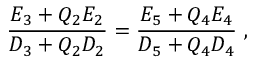<formula> <loc_0><loc_0><loc_500><loc_500>\frac { E _ { 3 } + Q _ { 2 } E _ { 2 } } { D _ { 3 } + Q _ { 2 } D _ { 2 } } = \frac { E _ { 5 } + Q _ { 4 } E _ { 4 } } { D _ { 5 } + Q _ { 4 } D _ { 4 } } \ ,</formula> 